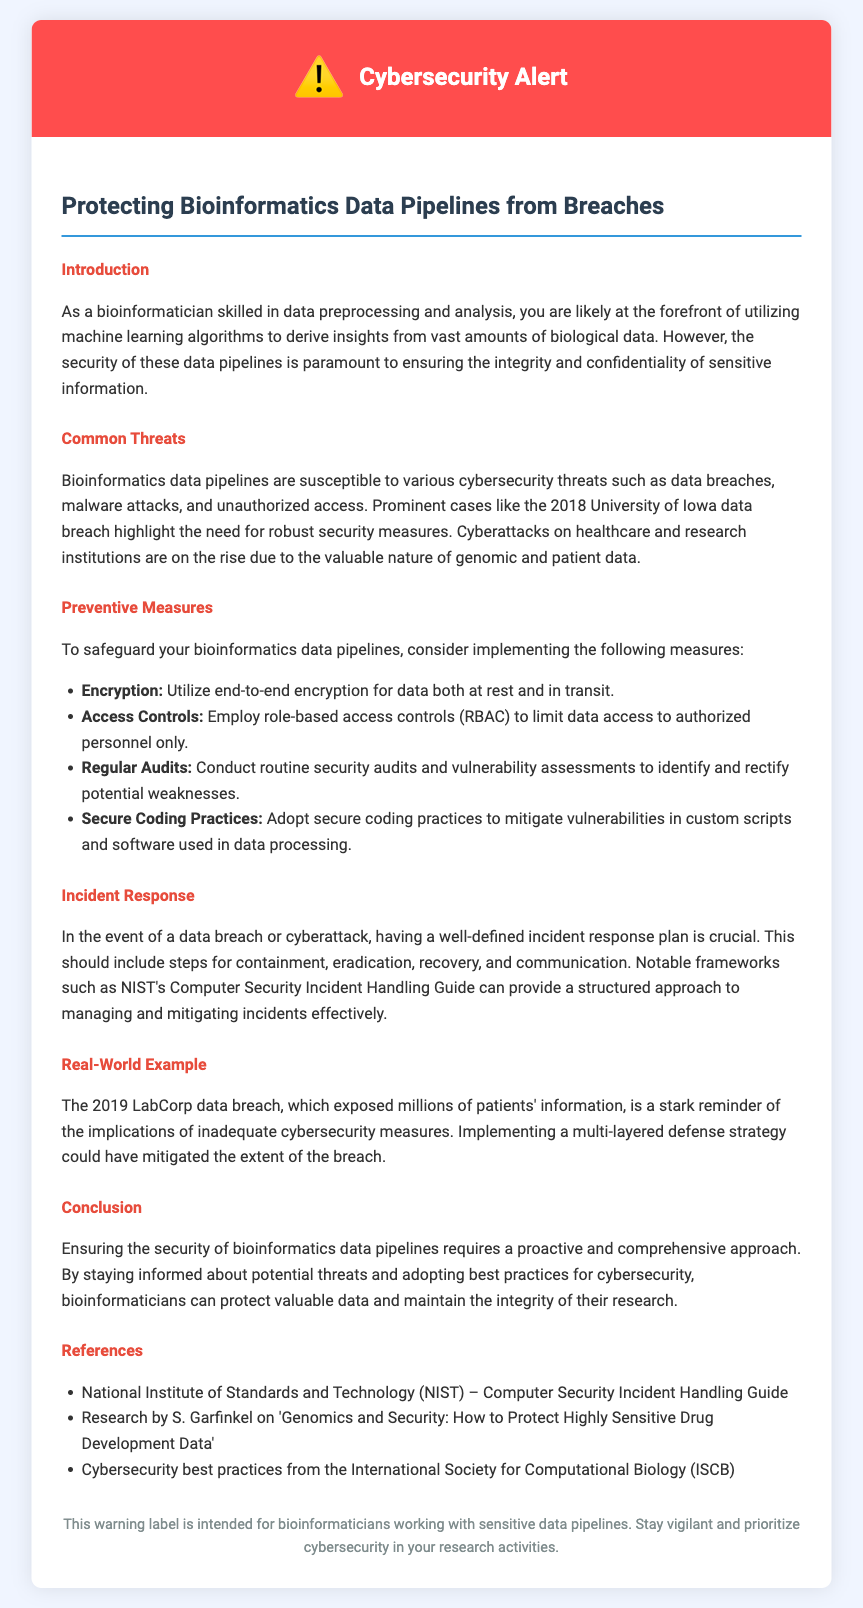What is the title of the document? The title is provided in the document head section and prominently displayed at the top.
Answer: Cybersecurity Alert: Protecting Bioinformatics Data Pipelines What is the warning icon symbol used in the document? The document features a warning icon displayed in the header section alongside the title.
Answer: ⚠️ Which case highlighted the need for robust security measures? The document mentions a significant data breach case as an example of cybersecurity threats in the context of bioinformatics.
Answer: 2018 University of Iowa data breach What is one of the preventive measures suggested in the document? Preventive measures are listed under the respective section and focus on improving security practices.
Answer: Encryption What major cybersecurity framework is mentioned for incident response? The document specifies a framework for managing and mitigating cybersecurity incidents in a structured manner.
Answer: NIST's Computer Security Incident Handling Guide What year did the LabCorp data breach occur? The document refers to a specific data breach incident and the year it happened, serving as a real-world example.
Answer: 2019 What is recommended for data access management? The document discusses a method for controlling who can access data within bioinformatics pipelines.
Answer: Role-based access controls (RBAC) What type of audits does the document recommend conducting regularly? The document emphasizes the importance of a specific type of audit to maintain security over time.
Answer: Security audits In which section are references provided? References are specifically listed in a designated section at the end of the document.
Answer: References 